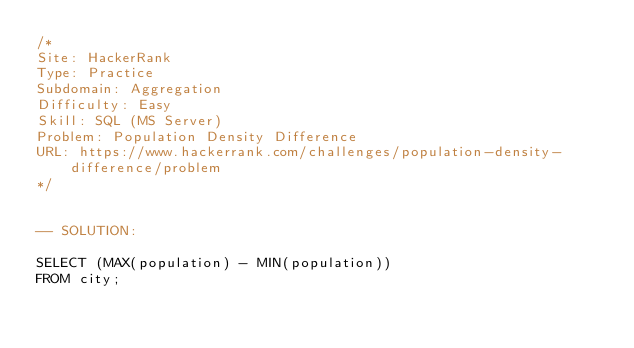<code> <loc_0><loc_0><loc_500><loc_500><_SQL_>/*
Site: HackerRank
Type: Practice
Subdomain: Aggregation
Difficulty: Easy
Skill: SQL (MS Server)
Problem: Population Density Difference
URL: https://www.hackerrank.com/challenges/population-density-difference/problem
*/


-- SOLUTION:

SELECT (MAX(population) - MIN(population)) 
FROM city;</code> 